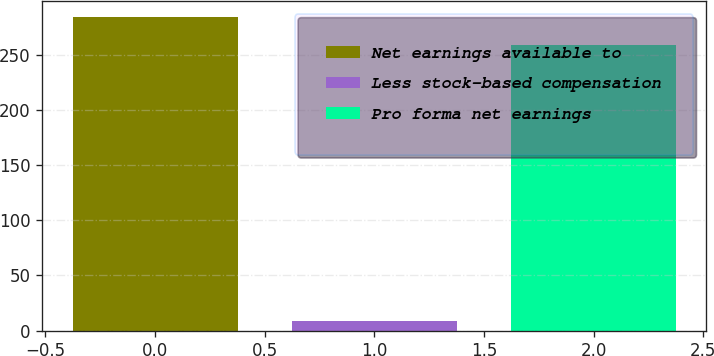<chart> <loc_0><loc_0><loc_500><loc_500><bar_chart><fcel>Net earnings available to<fcel>Less stock-based compensation<fcel>Pro forma net earnings<nl><fcel>284.8<fcel>9<fcel>259<nl></chart> 